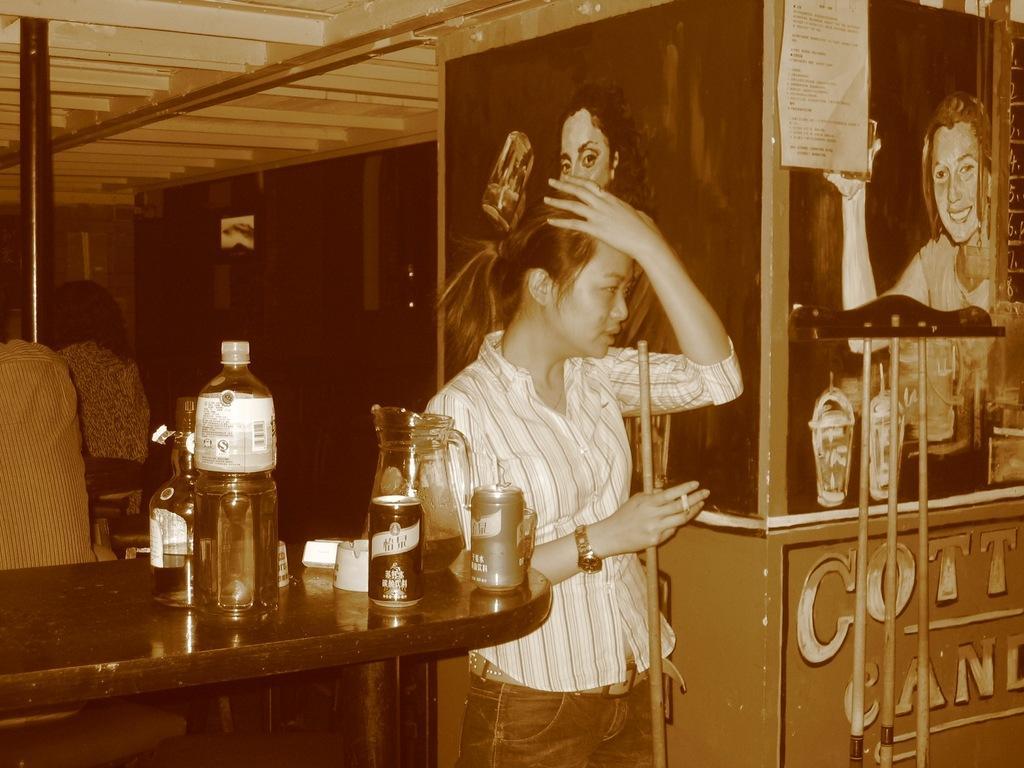Describe this image in one or two sentences. This picture shows a woman standing and holding a stick in her hand and we see few Bottles and cans on the table and we see few posters on the wall 